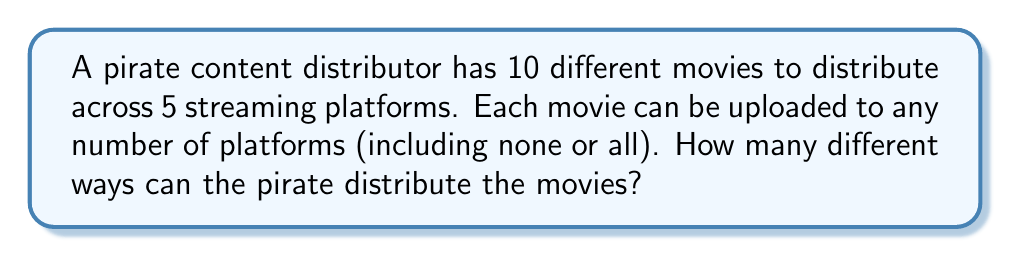Can you solve this math problem? Let's approach this step-by-step:

1) For each movie, we have 2 choices for each platform: upload or don't upload.

2) Since there are 5 platforms, for each movie we have $2^5 = 32$ choices.

3) This is because for each platform, we multiply the number of choices:
   $2 \times 2 \times 2 \times 2 \times 2 = 2^5 = 32$

4) Now, we have 10 different movies, and for each movie we make this choice independently.

5) Therefore, we multiply the number of choices for each movie:
   $32 \times 32 \times ... \times 32$ (10 times)

6) This can be written as $32^{10}$ or $(2^5)^{10}$

7) Using the power rule of exponents, this simplifies to $2^{50}$

Thus, the total number of ways to distribute the movies is $2^{50}$.
Answer: $2^{50}$ 